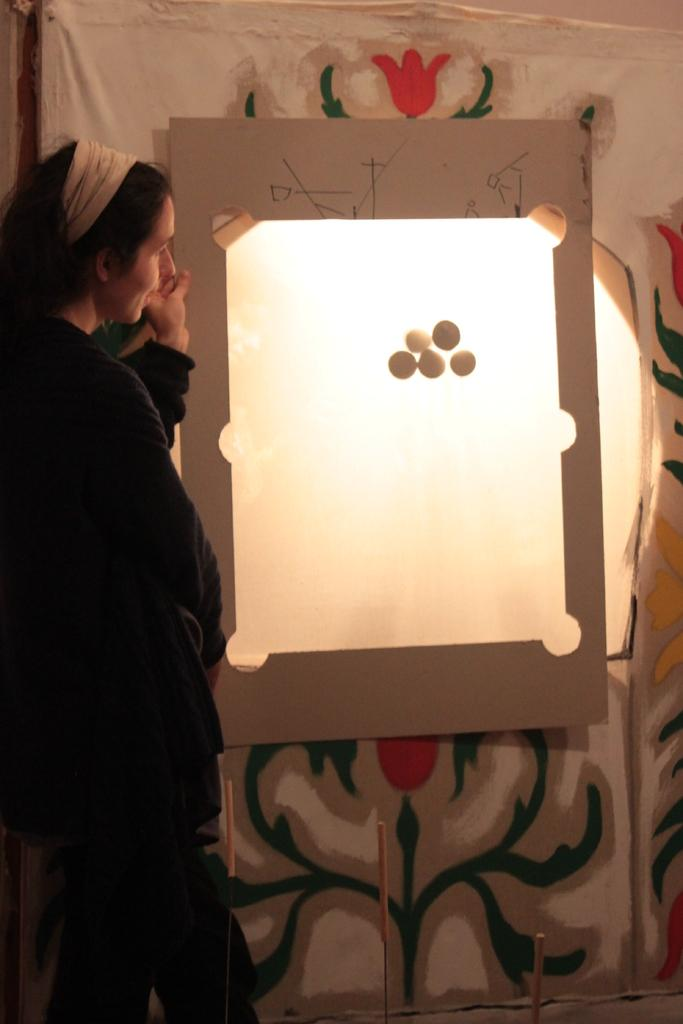What is the primary subject in the image? There is a woman standing in the image. What is the board used for in the image? The purpose of the board in the image is not specified, but it is present. Can you describe any other objects in the image besides the woman and the board? Yes, there are other objects present in the image, but their specific details are not mentioned in the provided facts. What color is the ink on the mask in the image? There is no ink or mask present in the image; only a woman and a board are mentioned. 